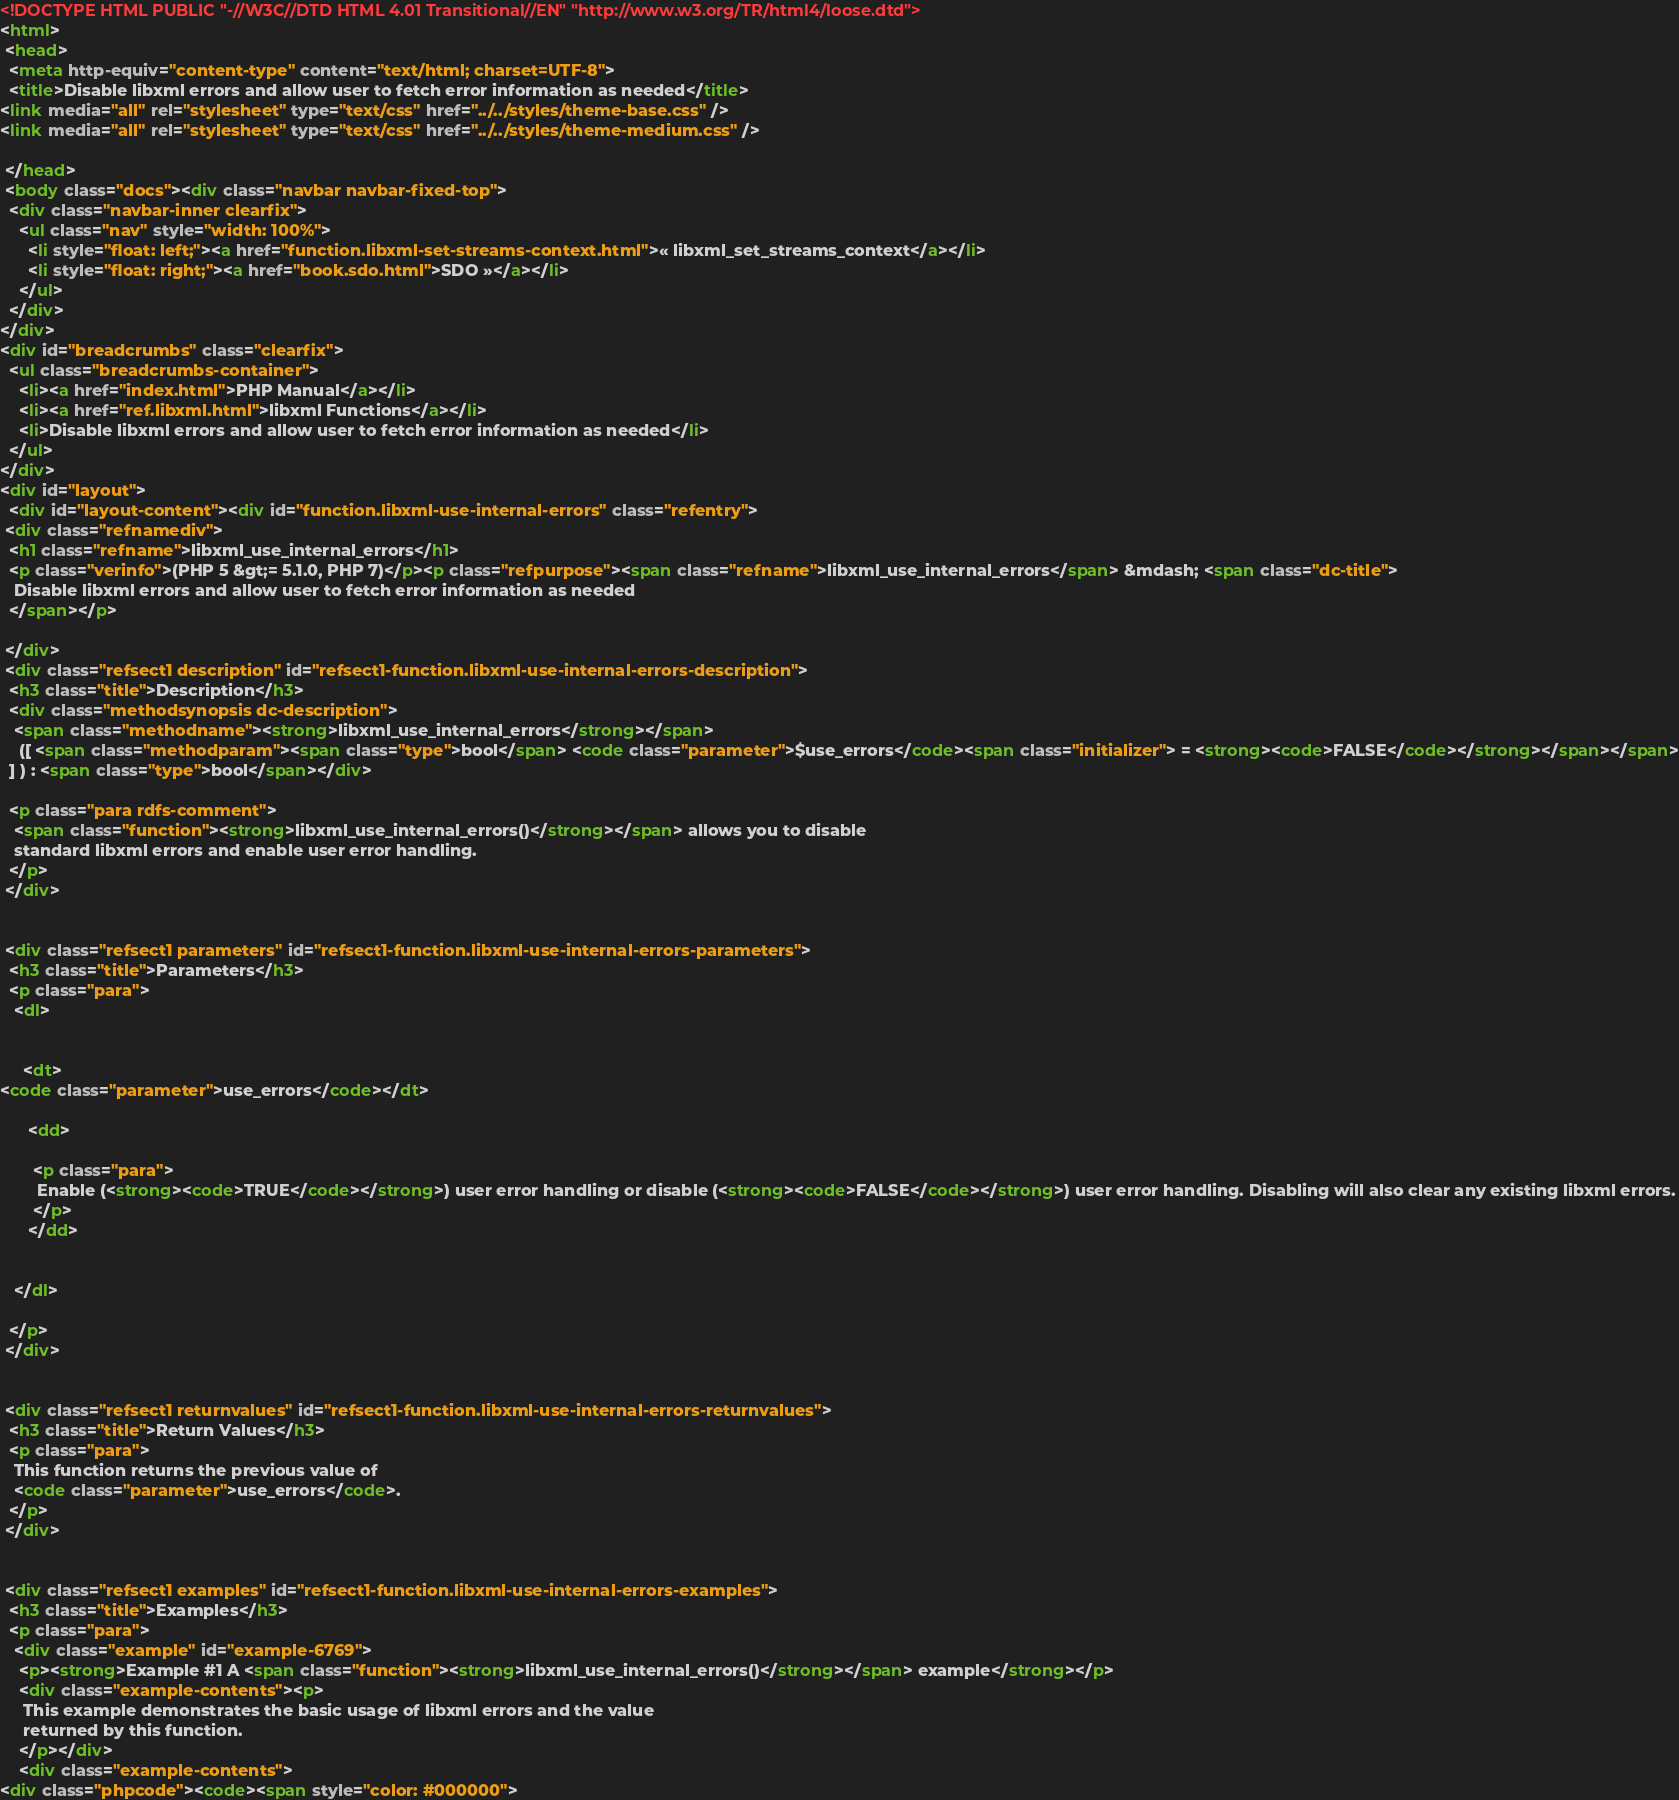Convert code to text. <code><loc_0><loc_0><loc_500><loc_500><_HTML_><!DOCTYPE HTML PUBLIC "-//W3C//DTD HTML 4.01 Transitional//EN" "http://www.w3.org/TR/html4/loose.dtd">
<html>
 <head>
  <meta http-equiv="content-type" content="text/html; charset=UTF-8">
  <title>Disable libxml errors and allow user to fetch error information as needed</title>
<link media="all" rel="stylesheet" type="text/css" href="../../styles/theme-base.css" />
<link media="all" rel="stylesheet" type="text/css" href="../../styles/theme-medium.css" />

 </head>
 <body class="docs"><div class="navbar navbar-fixed-top">
  <div class="navbar-inner clearfix">
    <ul class="nav" style="width: 100%">
      <li style="float: left;"><a href="function.libxml-set-streams-context.html">« libxml_set_streams_context</a></li>
      <li style="float: right;"><a href="book.sdo.html">SDO »</a></li>
    </ul>
  </div>
</div>
<div id="breadcrumbs" class="clearfix">
  <ul class="breadcrumbs-container">
    <li><a href="index.html">PHP Manual</a></li>
    <li><a href="ref.libxml.html">libxml Functions</a></li>
    <li>Disable libxml errors and allow user to fetch error information as needed</li>
  </ul>
</div>
<div id="layout">
  <div id="layout-content"><div id="function.libxml-use-internal-errors" class="refentry">
 <div class="refnamediv">
  <h1 class="refname">libxml_use_internal_errors</h1>
  <p class="verinfo">(PHP 5 &gt;= 5.1.0, PHP 7)</p><p class="refpurpose"><span class="refname">libxml_use_internal_errors</span> &mdash; <span class="dc-title">
   Disable libxml errors and allow user to fetch error information as needed
  </span></p>

 </div>
 <div class="refsect1 description" id="refsect1-function.libxml-use-internal-errors-description">
  <h3 class="title">Description</h3>
  <div class="methodsynopsis dc-description">
   <span class="methodname"><strong>libxml_use_internal_errors</strong></span>
    ([ <span class="methodparam"><span class="type">bool</span> <code class="parameter">$use_errors</code><span class="initializer"> = <strong><code>FALSE</code></strong></span></span>
  ] ) : <span class="type">bool</span></div>

  <p class="para rdfs-comment">
   <span class="function"><strong>libxml_use_internal_errors()</strong></span> allows you to disable
   standard libxml errors and enable user error handling.
  </p>
 </div>


 <div class="refsect1 parameters" id="refsect1-function.libxml-use-internal-errors-parameters">
  <h3 class="title">Parameters</h3>
  <p class="para">
   <dl>

    
     <dt>
<code class="parameter">use_errors</code></dt>

      <dd>

       <p class="para">
        Enable (<strong><code>TRUE</code></strong>) user error handling or disable (<strong><code>FALSE</code></strong>) user error handling. Disabling will also clear any existing libxml errors.
       </p>
      </dd>

     
   </dl>

  </p>
 </div>


 <div class="refsect1 returnvalues" id="refsect1-function.libxml-use-internal-errors-returnvalues">
  <h3 class="title">Return Values</h3>
  <p class="para">
   This function returns the previous value of
   <code class="parameter">use_errors</code>.
  </p>
 </div>


 <div class="refsect1 examples" id="refsect1-function.libxml-use-internal-errors-examples">
  <h3 class="title">Examples</h3>
  <p class="para">
   <div class="example" id="example-6769">
    <p><strong>Example #1 A <span class="function"><strong>libxml_use_internal_errors()</strong></span> example</strong></p>
    <div class="example-contents"><p>
     This example demonstrates the basic usage of libxml errors and the value
     returned by this function.
    </p></div>
    <div class="example-contents">
<div class="phpcode"><code><span style="color: #000000"></code> 